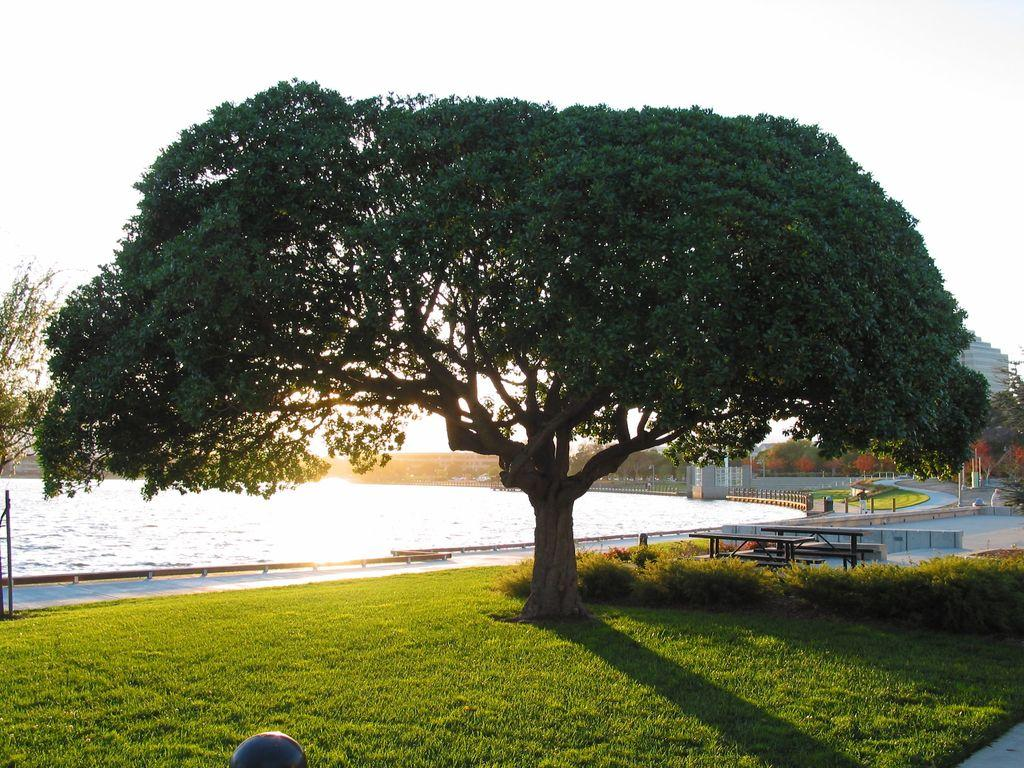What type of vegetation is present on the ground in the image? There is green grass on the ground in the image. What other green object can be seen in the image? There is a green color tree in the image. What is the water visible in the image? The water is visible in the image, but its specific location or purpose is not mentioned. What is visible at the top of the image? The sky is visible at the top of the image. What type of wish can be granted by the tree in the image? There is no mention of wishes or any magical properties associated with the tree in the image. What kind of offer is being made by the water in the image? There is no mention of offers or any actions being performed by the water in the image. 